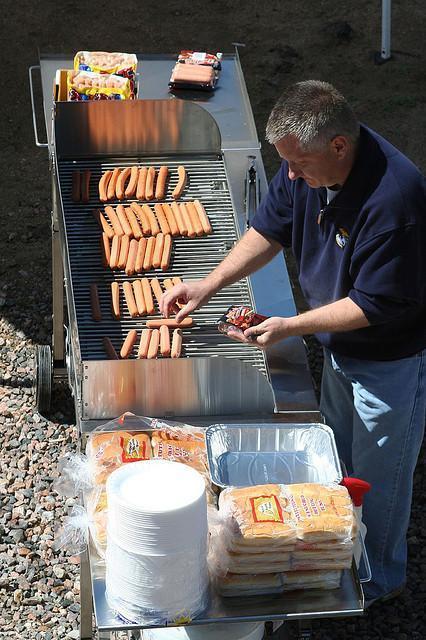How many bowls can be seen?
Give a very brief answer. 1. How many cars have headlights on?
Give a very brief answer. 0. 